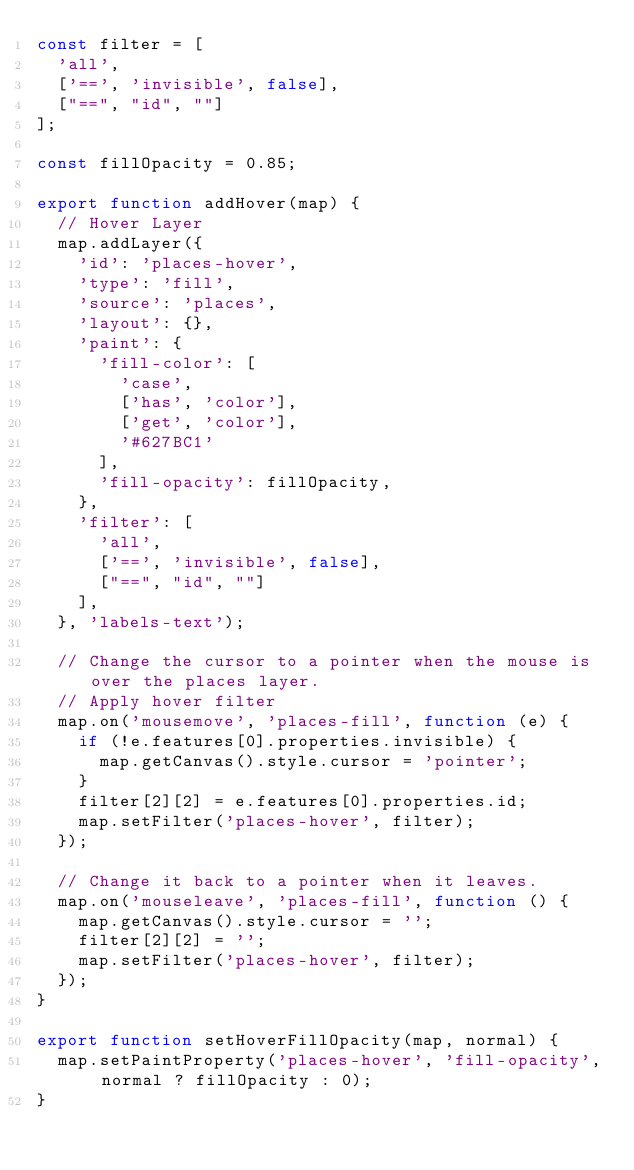<code> <loc_0><loc_0><loc_500><loc_500><_JavaScript_>const filter = [
  'all',
  ['==', 'invisible', false],
  ["==", "id", ""]
];

const fillOpacity = 0.85;

export function addHover(map) {
  // Hover Layer
  map.addLayer({
    'id': 'places-hover',
    'type': 'fill',
    'source': 'places',
    'layout': {},
    'paint': {
      'fill-color': [
        'case',
        ['has', 'color'],
        ['get', 'color'],
        '#627BC1'
      ],
      'fill-opacity': fillOpacity,
    },
    'filter': [
      'all',
      ['==', 'invisible', false],
      ["==", "id", ""]
    ],
  }, 'labels-text');

  // Change the cursor to a pointer when the mouse is over the places layer.
  // Apply hover filter
  map.on('mousemove', 'places-fill', function (e) {
    if (!e.features[0].properties.invisible) {
      map.getCanvas().style.cursor = 'pointer';
    }
    filter[2][2] = e.features[0].properties.id;
    map.setFilter('places-hover', filter);
  });

  // Change it back to a pointer when it leaves.
  map.on('mouseleave', 'places-fill', function () {
    map.getCanvas().style.cursor = '';
    filter[2][2] = '';
    map.setFilter('places-hover', filter);
  });
}

export function setHoverFillOpacity(map, normal) {
  map.setPaintProperty('places-hover', 'fill-opacity', normal ? fillOpacity : 0);
}
</code> 